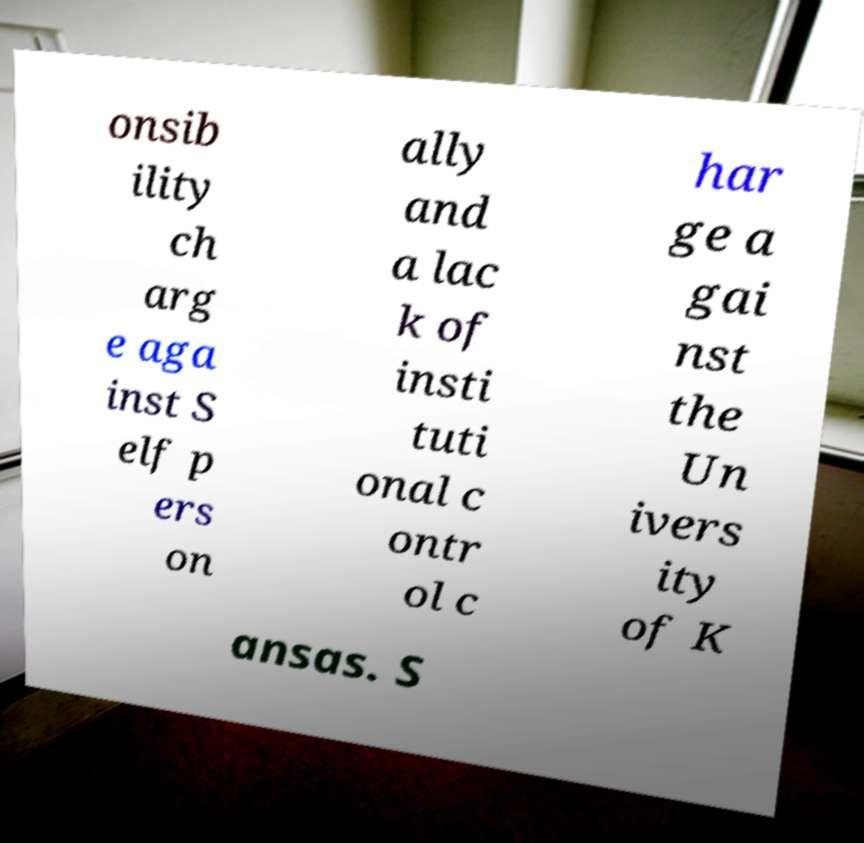Could you assist in decoding the text presented in this image and type it out clearly? onsib ility ch arg e aga inst S elf p ers on ally and a lac k of insti tuti onal c ontr ol c har ge a gai nst the Un ivers ity of K ansas. S 